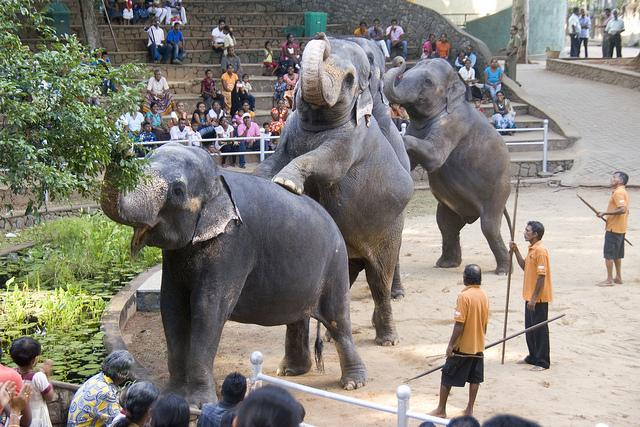What animals might be found in the pond here? elephants 